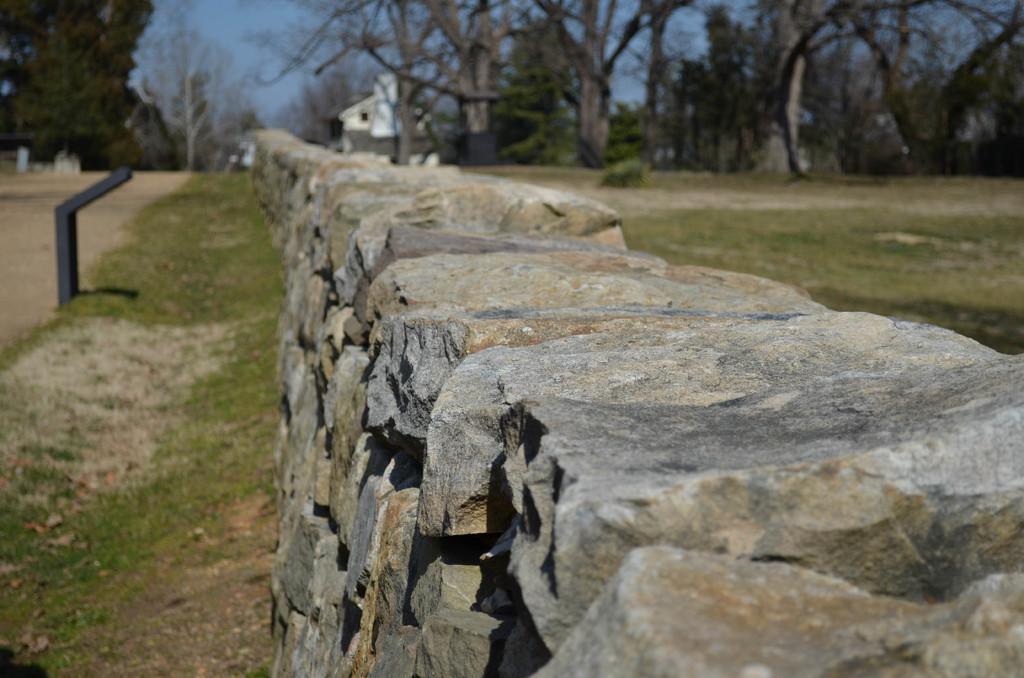Please provide a concise description of this image. In the picture we can see a rock wall and on the either sides of the wall we can see grass surface and in the background, we can see some trees and behind it, we can see a house and some trees near it and behind it we can see a sky. 